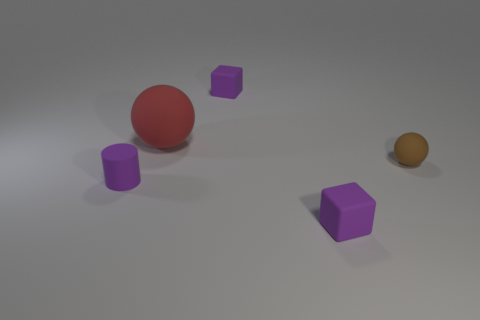Are there any other things that are the same size as the red object?
Offer a terse response. No. How many objects are both to the right of the purple matte cylinder and to the left of the tiny brown thing?
Offer a very short reply. 3. How many purple blocks are behind the matte thing that is to the right of the block that is in front of the red rubber thing?
Make the answer very short. 1. There is a brown thing; what shape is it?
Provide a short and direct response. Sphere. How many large red things are the same material as the tiny purple cylinder?
Your answer should be very brief. 1. There is a tiny cylinder that is made of the same material as the tiny sphere; what color is it?
Keep it short and to the point. Purple. There is a red thing; is it the same size as the brown rubber thing behind the small rubber cylinder?
Keep it short and to the point. No. What is the material of the ball that is right of the small matte cube in front of the tiny purple rubber block that is behind the brown rubber object?
Keep it short and to the point. Rubber. How many things are either big things or matte spheres?
Ensure brevity in your answer.  2. There is a small rubber cube that is in front of the purple matte cylinder; does it have the same color as the rubber thing to the left of the red ball?
Provide a succinct answer. Yes. 